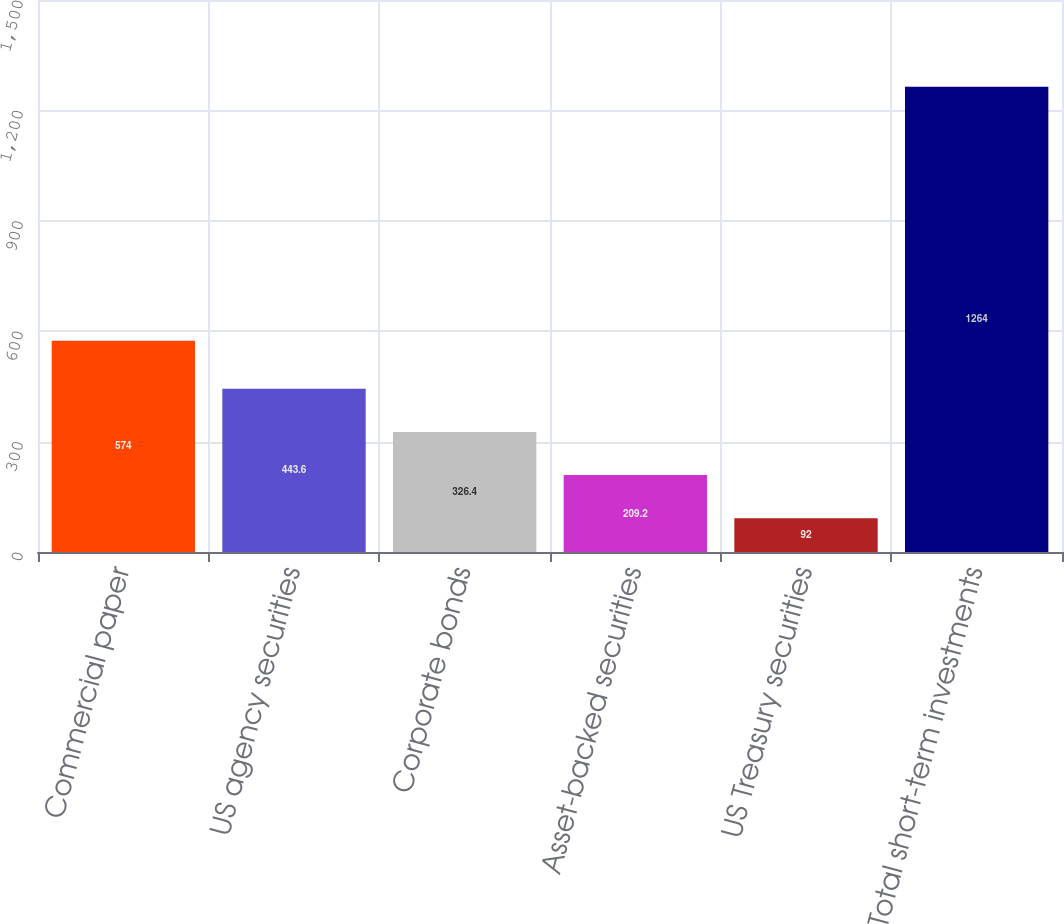Convert chart to OTSL. <chart><loc_0><loc_0><loc_500><loc_500><bar_chart><fcel>Commercial paper<fcel>US agency securities<fcel>Corporate bonds<fcel>Asset-backed securities<fcel>US Treasury securities<fcel>Total short-term investments<nl><fcel>574<fcel>443.6<fcel>326.4<fcel>209.2<fcel>92<fcel>1264<nl></chart> 